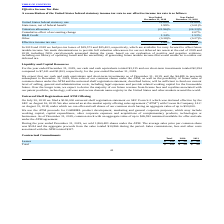According to Virnetx Holding's financial document, What were the pre-tax losses in 2019? According to the financial document, $19,573. The relevant text states: "In 2019 and 2018 we had pre-tax losses of $19,573 and $25,403, respectively, which are available for carry forward to offset future taxable income. We..." Also, Why are pre-tax losses made available for carrying forward? To offset future taxable income. The document states: "spectively, which are available for carry forward to offset future taxable income. We made determinations to provide full valuation allowances for our..." Also, What was the R&D Credit in 2019? According to the financial document, 1.53%. The relevant text states: "R&D Credit 1.34% 1.53%..." Also, can you calculate: What was the 2019 percentage change in pre-tax losses? To answer this question, I need to perform calculations using the financial data. The calculation is: (19,573 - 25,403)/25,403 , which equals -22.95 (percentage). This is based on the information: "In 2019 and 2018 we had pre-tax losses of $19,573 and $25,403, respectively, which are available for carry forward to offset future taxable income. W 19 and 2018 we had pre-tax losses of $19,573 and $..." The key data points involved are: 19,573, 25,403. Also, can you calculate: What was the change in the United States federal statutory rate between 2018 and 2019? I cannot find a specific answer to this question in the financial document. Additionally, Which year has a higher amount of pre-tax losses? According to the financial document, 2018. The relevant text states: "December 31, 2018 December 31, 2018..." 